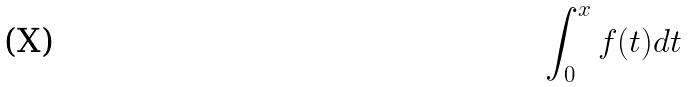<formula> <loc_0><loc_0><loc_500><loc_500>\int _ { 0 } ^ { x } f ( t ) d t</formula> 